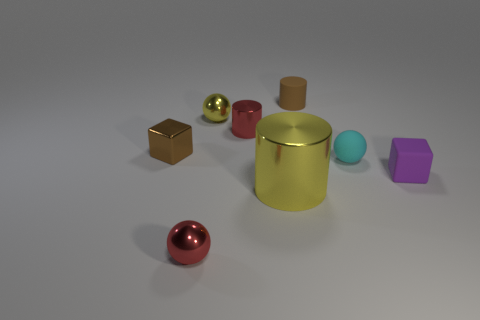Subtract all cylinders. How many objects are left? 5 Subtract 2 blocks. How many blocks are left? 0 Subtract all purple cubes. Subtract all green cylinders. How many cubes are left? 1 Subtract all green balls. How many brown cylinders are left? 1 Subtract all small red metallic things. Subtract all tiny brown rubber balls. How many objects are left? 6 Add 3 metal things. How many metal things are left? 8 Add 5 small spheres. How many small spheres exist? 8 Add 2 large cyan things. How many objects exist? 10 Subtract all red spheres. How many spheres are left? 2 Subtract all tiny metal spheres. How many spheres are left? 1 